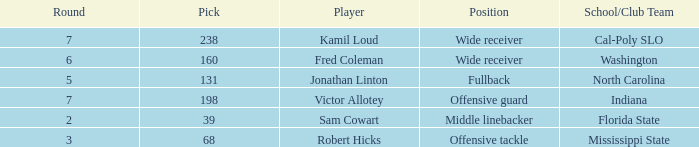Which Round has a School/Club Team of indiana, and a Pick smaller than 198? None. 